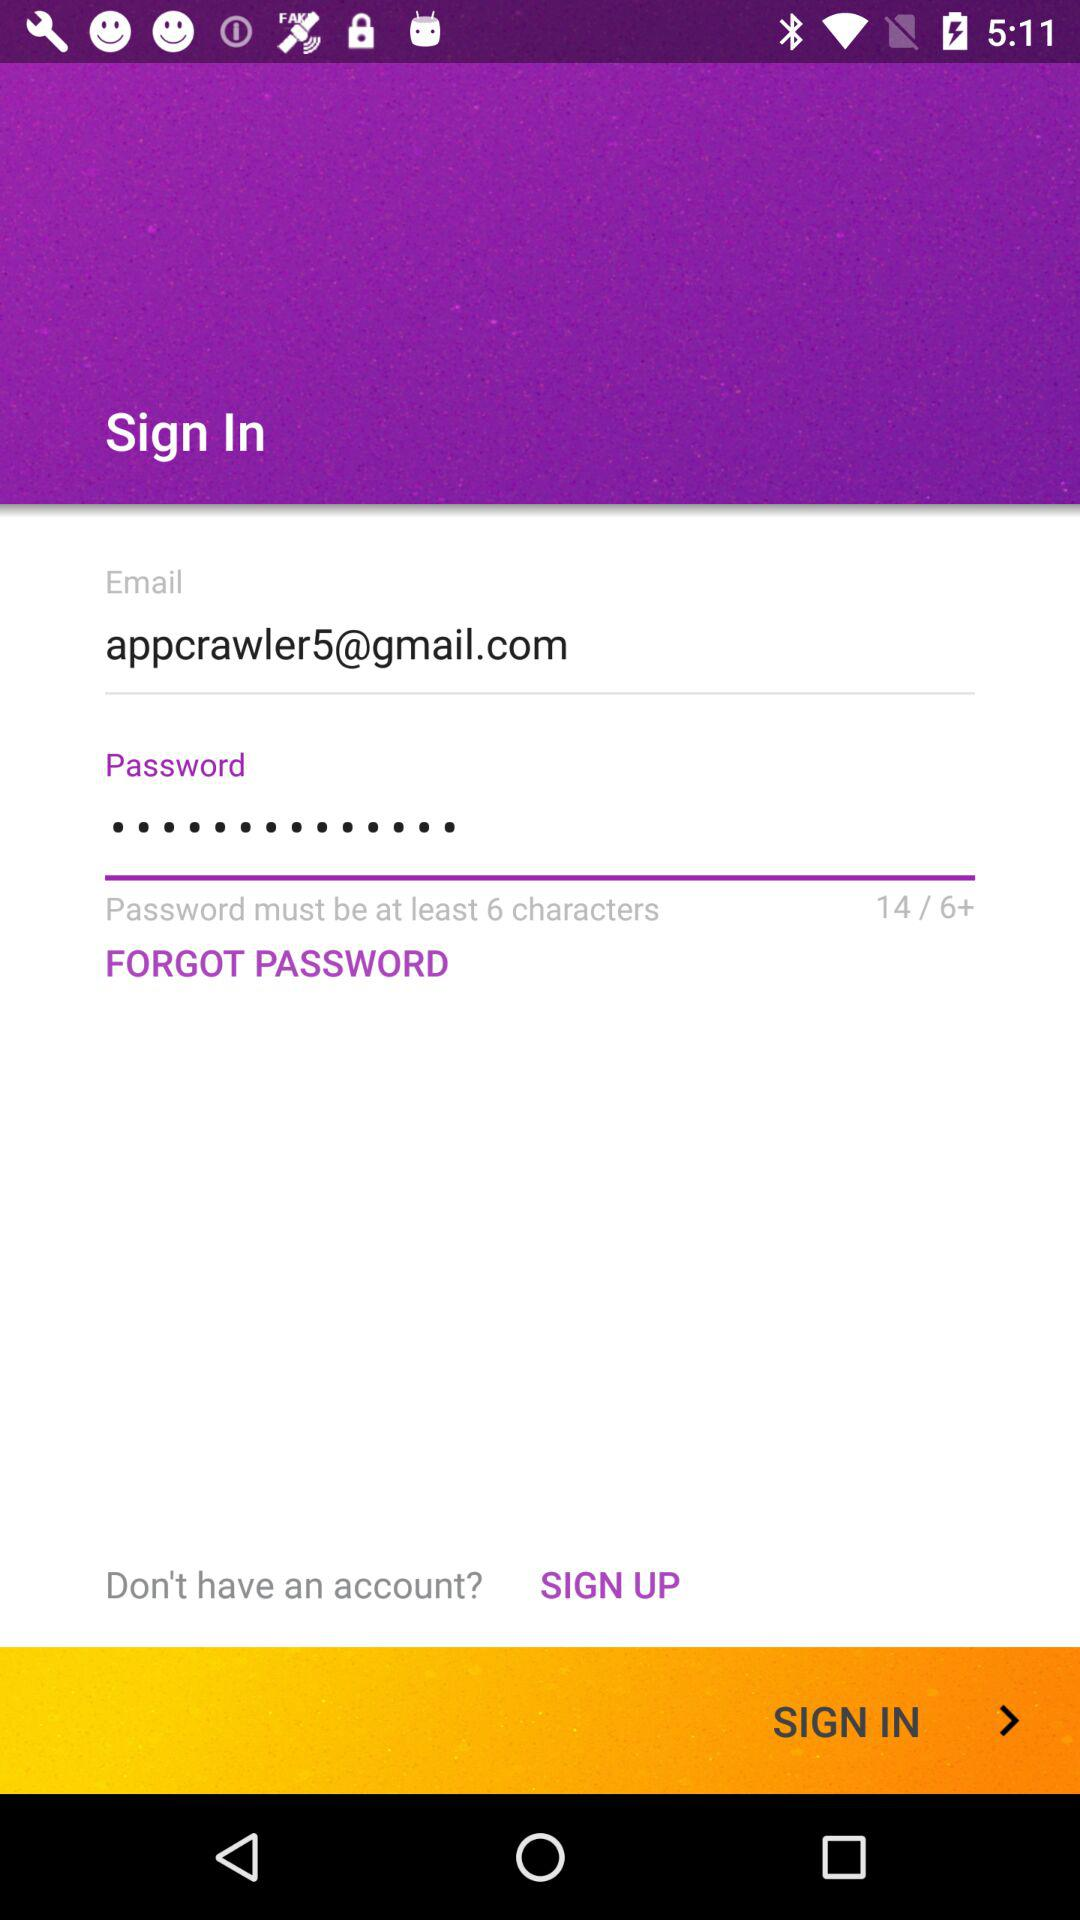How many characters must be in the password? There must be at least 6 characters in the password. 